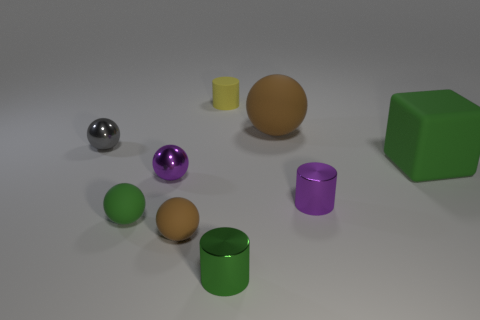Is there any other thing that has the same shape as the large green rubber object?
Provide a short and direct response. No. There is a brown object that is right of the tiny yellow thing; what is its material?
Offer a very short reply. Rubber. Does the tiny ball that is behind the big green matte object have the same material as the big green object?
Your answer should be very brief. No. How many things are either cylinders or matte balls left of the green cylinder?
Make the answer very short. 5. There is a purple shiny object that is the same shape as the large brown thing; what is its size?
Make the answer very short. Small. Is there anything else that is the same size as the green rubber ball?
Ensure brevity in your answer.  Yes. Are there any tiny matte objects behind the yellow cylinder?
Offer a very short reply. No. Is the color of the rubber sphere right of the matte cylinder the same as the tiny rubber object that is behind the block?
Offer a terse response. No. Is there a small gray metallic thing that has the same shape as the tiny green matte object?
Provide a succinct answer. Yes. How many other things are there of the same color as the matte block?
Provide a short and direct response. 2. 